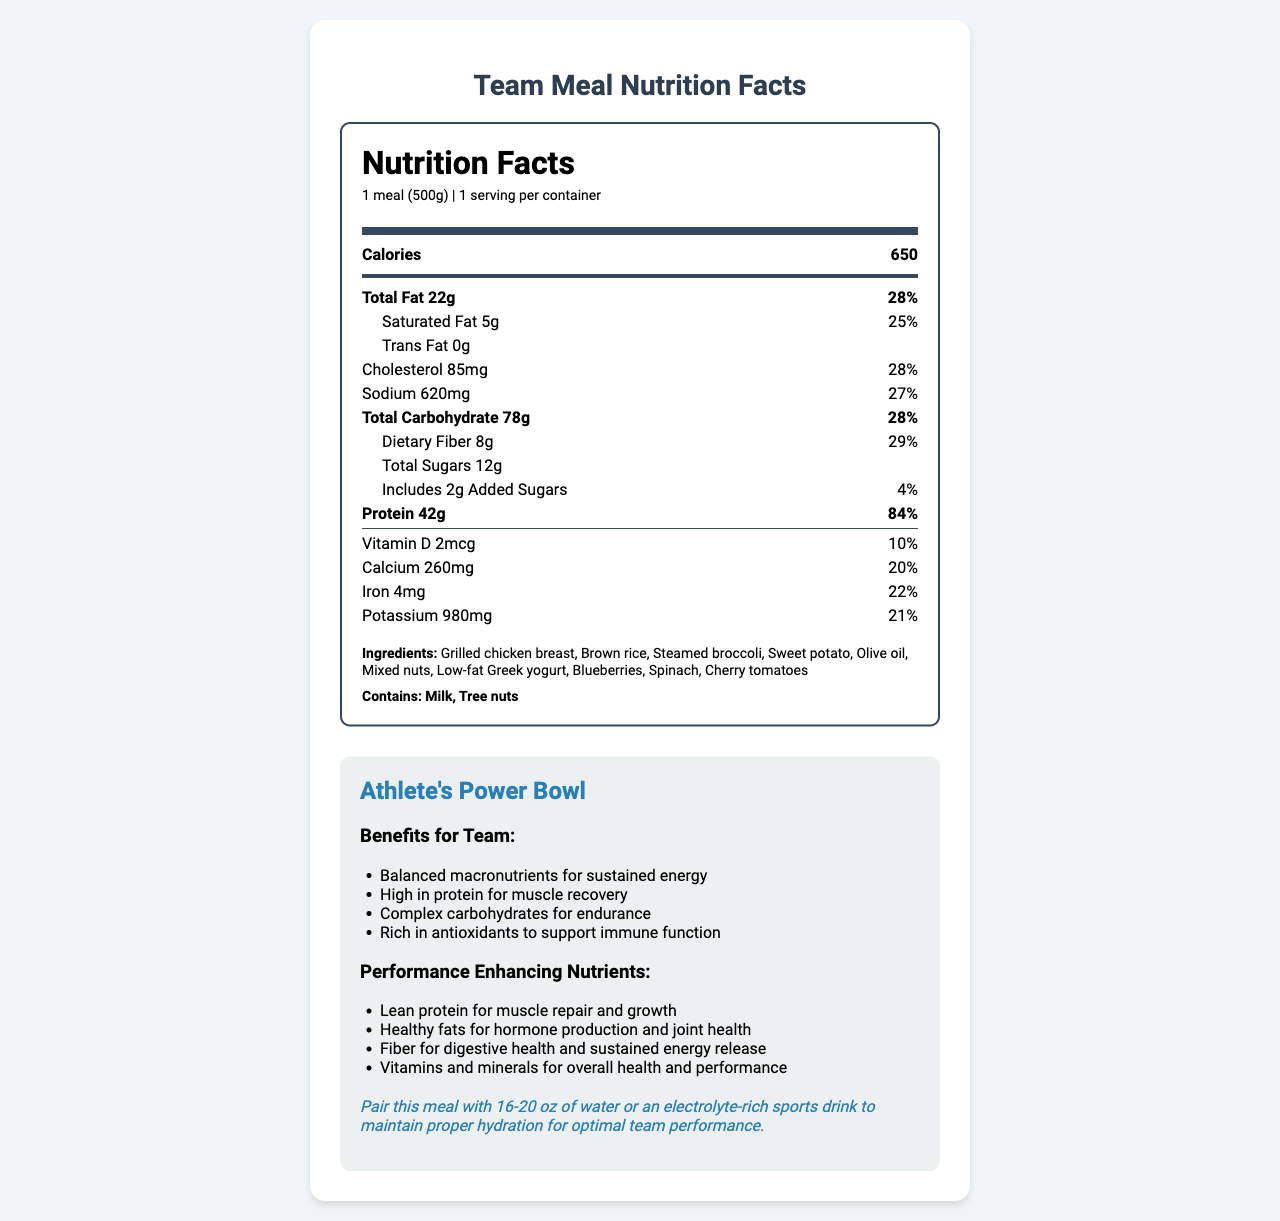what is the serving size for the meal? The serving size is indicated at the top of the nutrition label, stating "1 meal (500g)".
Answer: 1 meal (500g) how many calories are in one serving of this meal? The nutrition label lists the total calories for one serving as 650.
Answer: 650 calories what are the main ingredients in this meal? The ingredients are listed at the bottom of the nutrition facts under "Ingredients".
Answer: Grilled chicken breast, Brown rice, Steamed broccoli, Sweet potato, Olive oil, Mixed nuts, Low-fat Greek yogurt, Blueberries, Spinach, Cherry tomatoes how much protein does this meal provide? The nutrition label shows that the meal provides 42g of protein per serving.
Answer: 42g what is the total carbohydrate content in this meal? The nutrition label lists the total carbohydrate content as 78g.
Answer: 78g which of the following statements is true? A. This meal contains 5g of trans fat. B. This meal provides 84% of the daily value for protein. C. This meal has 500mg of sodium. Statement A is false as the meal contains 0g of trans fat. Statement C is false as the meal contains 620mg of sodium. Statement B is true, as it matches the protein daily value percentage on the label.
Answer: B how much dietary fiber is in this meal? A. 5g B. 8g C. 12g D. 10g The nutrition facts label lists the dietary fiber content as 8g.
Answer: B does this meal contain any allergens? The allergens listed are milk and tree nuts.
Answer: Yes summarize the main idea of this document. The document includes a detailed nutrition label followed by team meal plan information. It highlights the meal's benefits for athletes, performance-enhancing nutrients, ingredients, and any allergens.
Answer: This document provides the nutrition facts for a balanced team meal, specifically the "Athlete's Power Bowl". The meal is designed for optimal athletic performance and includes details about its macronutrient breakdown, ingredients, and performance-enhancing nutrients. Additionally, it offers hydration tips. can you determine the exact recipe of the "Athlete's Power Bowl" from this document? The document lists the ingredients but does not provide specific quantities or preparation instructions for the recipe.
Answer: Not enough information what is the daily value percentage of calcium provided by this meal? The nutrition facts label indicates that the meal provides 20% of the daily value for calcium.
Answer: 20% based on the document, which nutrient has the highest daily value percentage in this meal? The nutrition facts label shows that protein has the highest daily value percentage at 84%.
Answer: Protein what is the hydration recommendation provided with this meal? The hydration tip is included in the team meal plan information section at the bottom of the document.
Answer: Pair this meal with 16-20 oz of water or an electrolyte-rich sports drink to maintain proper hydration for optimal team performance. 